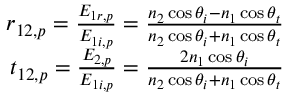<formula> <loc_0><loc_0><loc_500><loc_500>\begin{array} { r } { r _ { 1 2 , p } = \frac { E _ { 1 r , p } } { E _ { 1 i , p } } = \frac { n _ { 2 } \cos \theta _ { i } - n _ { 1 } \cos \theta _ { t } } { n _ { 2 } \cos \theta _ { i } + n _ { 1 } \cos \theta _ { t } } } \\ { t _ { 1 2 , p } = \frac { E _ { 2 , p } } { E _ { 1 i , p } } = \frac { 2 n _ { 1 } \cos \theta _ { i } } { n _ { 2 } \cos \theta _ { i } + n _ { 1 } \cos \theta _ { t } } } \end{array}</formula> 